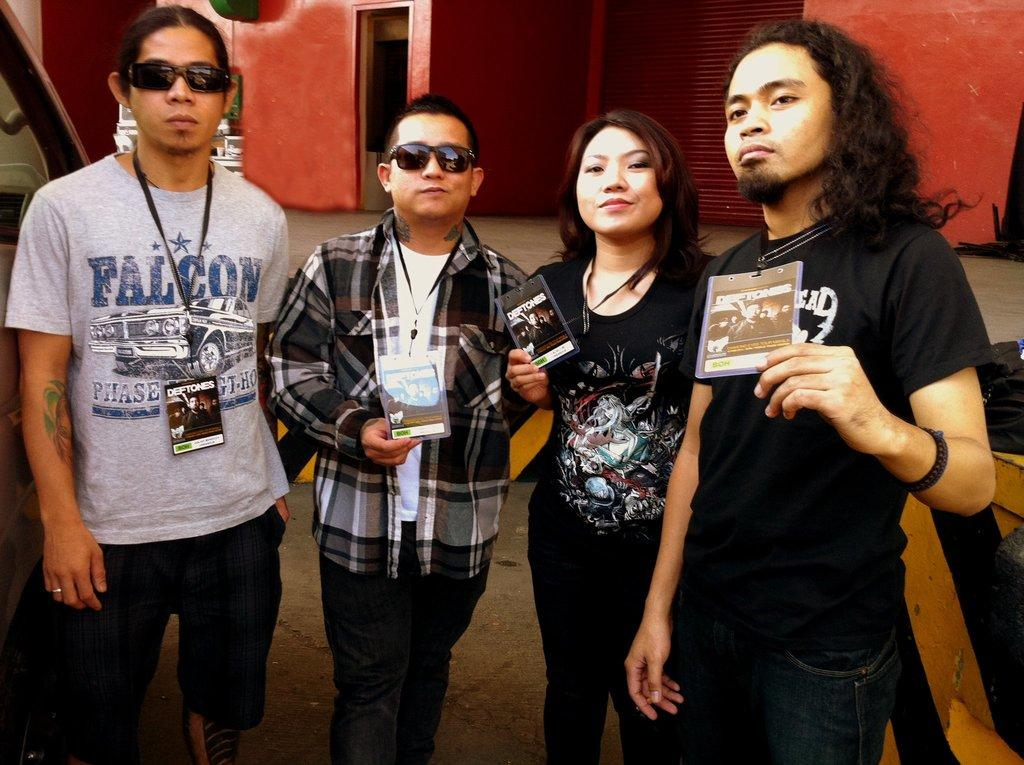How many people are in the image? There are four persons standing in the middle of the image. What are the expressions on the faces of the persons? The persons are smiling. What are the persons holding in their hands? The persons are holding tags. What is located behind the persons? There is a wall behind the persons. What can be seen beside the persons? There are two vehicles beside the persons. Can you see the moon in the image? No, the moon is not visible in the image. Is there a kitty playing with the persons in the image? No, there is no kitty present in the image. 